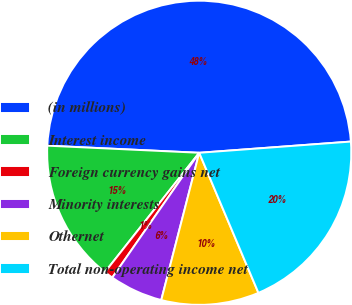Convert chart to OTSL. <chart><loc_0><loc_0><loc_500><loc_500><pie_chart><fcel>(in millions)<fcel>Interest income<fcel>Foreign currency gains net<fcel>Minority interests<fcel>Othernet<fcel>Total non-operating income net<nl><fcel>48.08%<fcel>15.1%<fcel>0.96%<fcel>5.67%<fcel>10.38%<fcel>19.81%<nl></chart> 